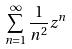Convert formula to latex. <formula><loc_0><loc_0><loc_500><loc_500>\sum _ { n = 1 } ^ { \infty } \frac { 1 } { n ^ { 2 } } z ^ { n }</formula> 